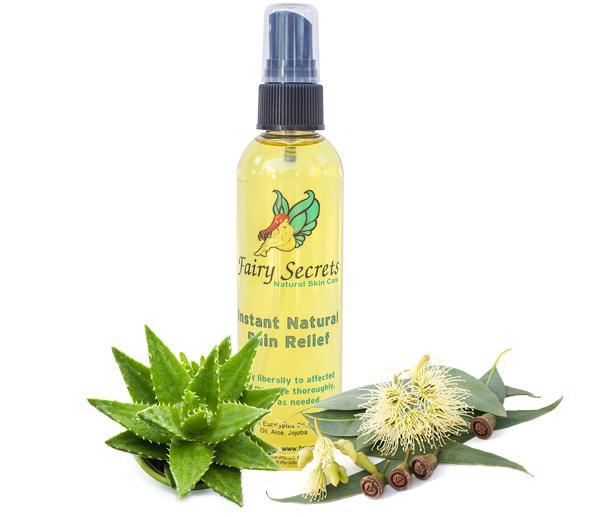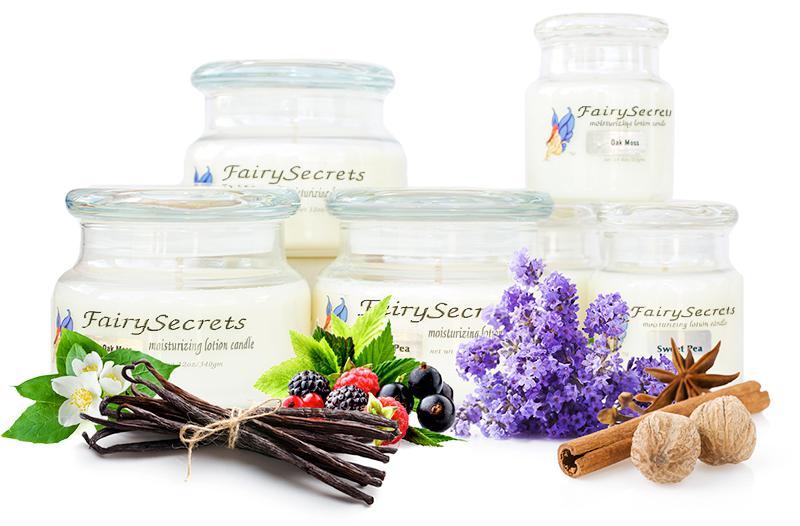The first image is the image on the left, the second image is the image on the right. For the images displayed, is the sentence "Each image includes products posed with sprig-type things from nature." factually correct? Answer yes or no. Yes. 